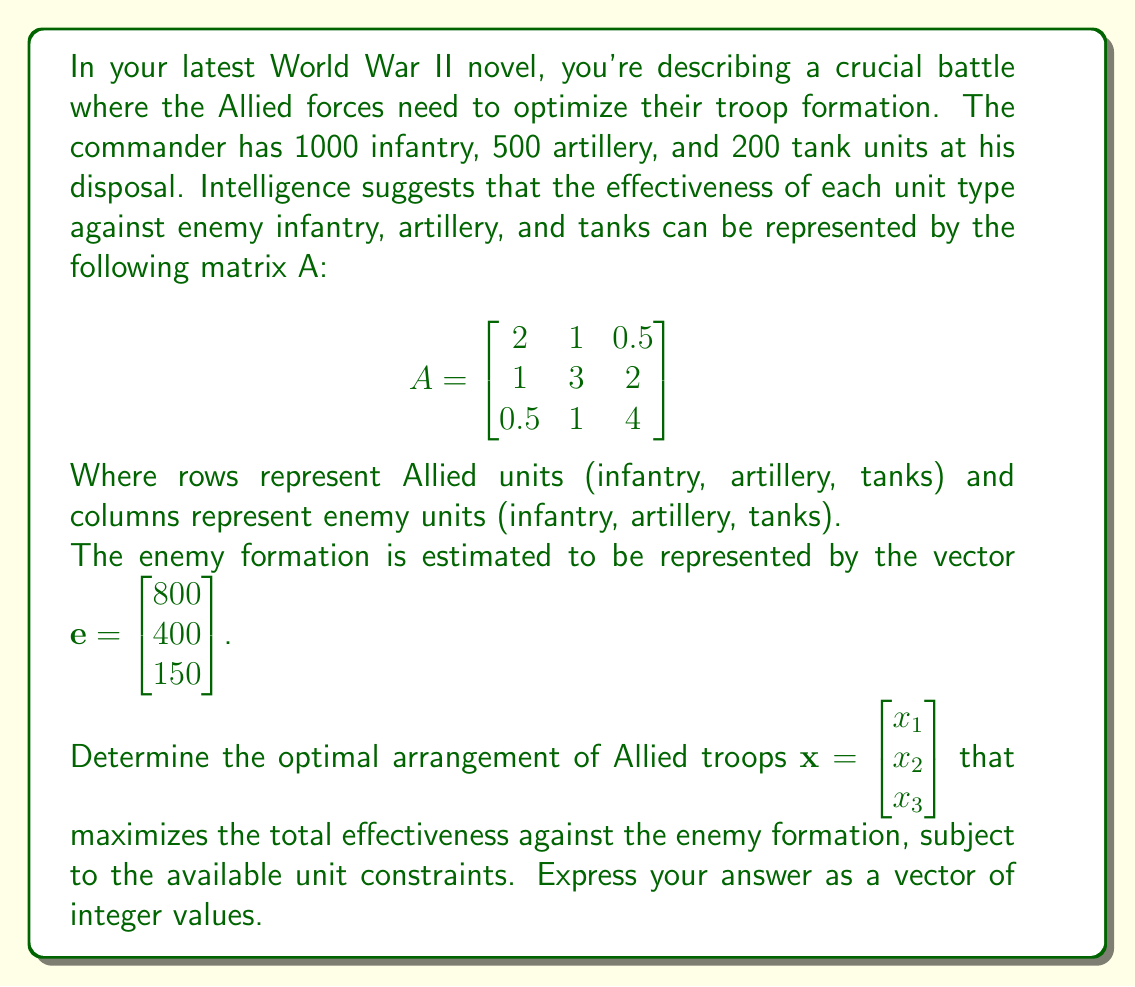Provide a solution to this math problem. To solve this problem, we need to maximize the dot product of $A\mathbf{x}$ and $\mathbf{e}$, subject to the constraints on available units. This can be formulated as a linear programming problem:

Maximize: $f(\mathbf{x}) = (A\mathbf{x})^T \mathbf{e}$

Subject to:
$x_1 + x_2 + x_3 \leq 1700$ (total available units)
$x_1 \leq 1000$ (infantry constraint)
$x_2 \leq 500$ (artillery constraint)
$x_3 \leq 200$ (tank constraint)
$x_1, x_2, x_3 \geq 0$ (non-negativity constraints)

Let's expand the objective function:

$f(\mathbf{x}) = (A\mathbf{x})^T \mathbf{e} = (2x_1 + x_2 + 0.5x_3)(800) + (x_1 + 3x_2 + x_3)(400) + (0.5x_1 + 2x_2 + 4x_3)(150)$

$f(\mathbf{x}) = 1600x_1 + 800x_2 + 400x_3 + 400x_1 + 1200x_2 + 400x_3 + 75x_1 + 300x_2 + 600x_3$

$f(\mathbf{x}) = 2075x_1 + 2300x_2 + 1400x_3$

To maximize this function subject to the given constraints, we need to allocate as many units as possible to the unit type with the highest coefficient, then move to the next highest, and so on. The coefficients in descending order are:

1. Artillery (x_2): 2300
2. Infantry (x_1): 2075
3. Tanks (x_3): 1400

Therefore, the optimal allocation is:

1. Allocate all 500 available artillery units
2. Allocate all 1000 available infantry units
3. Allocate the remaining 200 tank units

This solution satisfies all constraints and maximizes the effectiveness against the enemy formation.
Answer: $\mathbf{x} = \begin{bmatrix} 1000 \\ 500 \\ 200 \end{bmatrix}$ 